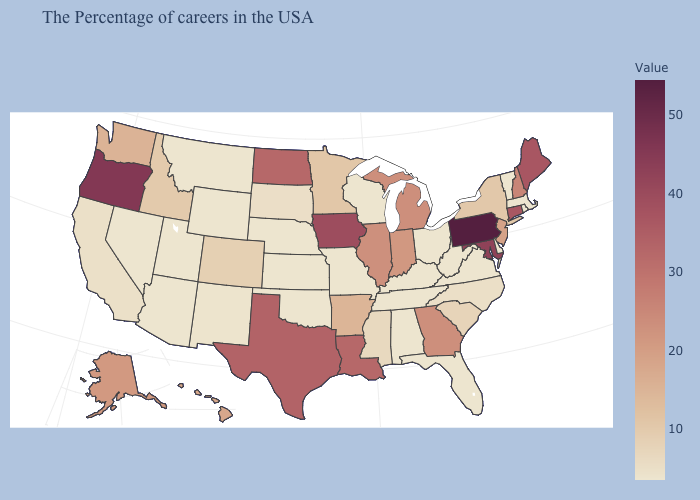Is the legend a continuous bar?
Quick response, please. Yes. Among the states that border Kentucky , which have the lowest value?
Give a very brief answer. Virginia, West Virginia, Ohio, Tennessee, Missouri. Which states have the lowest value in the USA?
Concise answer only. Massachusetts, Rhode Island, Vermont, Delaware, Virginia, West Virginia, Ohio, Florida, Kentucky, Alabama, Tennessee, Wisconsin, Missouri, Kansas, Nebraska, Oklahoma, Wyoming, Utah, Montana, Arizona, Nevada. Among the states that border Illinois , does Iowa have the lowest value?
Write a very short answer. No. Which states have the lowest value in the South?
Short answer required. Delaware, Virginia, West Virginia, Florida, Kentucky, Alabama, Tennessee, Oklahoma. Does California have the lowest value in the USA?
Short answer required. No. Among the states that border New Mexico , which have the highest value?
Quick response, please. Texas. 